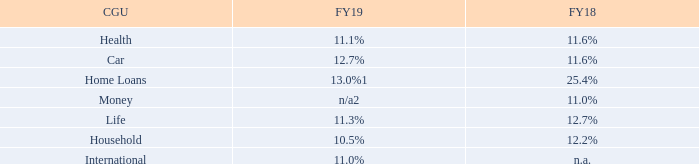Home Loans CGU
The recoverable amount of the Home loans CGU as at 31 December 2018 was determined at $5.6m based on a value-in-use calculation using cash flow projections from financial budgets approved by Senior Management covering a five-year period. The projected cash flows were updated to reflect a change in Senior Management and their initial views as part of a strategic review undertaken. The pre-tax discount rate applied to cash flow projections was 13% (30 June 2018: 25%) and cash flows beyond the five-year period were extrapolated using a 3% growth rate (30 June 2018: 3%). As a result of this analysis, management recognised an impairment charge of $4,450,000 against goodwill and capitalised software development costs. No other impairment was identified for the CGUs to which goodwill or brand names are allocated.
3.2 Goodwill and other intangible assets (continued)
Key estimates – value-in-use calculation
Cash flow projections
Our cash flow projections are based on five-year management-approved forecasts unless a longer period is justified. The forecasts use management estimates to determine income, expenses, capital expenditure and cash flows for each asset and CGU.
Discount rate
Discount rates represent the current market assessment of the risks specific to each CGU, taking into consideration the time value of money and individual risks of the underlying assets that have not been incorporated in the cash flow estimates. The discount rate calculation is based on the specific circumstances of the Group and its operating segments and is derived from its weighted average cost of capital (WACC). The WACC takes into account both debt and equity. The cost of equity is derived from the expected return on investment by the Group’s investors. The cost of debt is based on the interest bearing borrowings the Group is obliged to service. CGU-specific risk is incorporated into the WACC rate where it is considered appropriate. The pre-tax discount rates are as follows:
1 Discount rate based on impairment assessment completed on 31 December 2018 which resulted in full impairment of goodwill allocated to Home Loans CGU
2 Money CGU which consisted of the Infochoice business was sold to an independent third party on 18 February 2019. Refer to note 6.3 for details.
Growth rate estimates
For each CGU (excluding International), 5 years of cash flows have been included in the cash flow models. These are based on the long-term plan and growth rates of 3%.
Market share assumptions
These assumptions are important because management assesses how the unit’s position, relative to its competitors, might change over the budget period. Management expects the Group’s share of its respective markets to grow over the forecast period.
Sensitivity to changes in assumptions
With regard to the assessment of ‘value-in-use’ of the CGUs, management believes that no reasonable change in any of the above key assumptions would cause the carrying value of the units to materially exceed its recoverable amount.
What is the recoverable amount of the Home loans CGU as at 31 December 2018? $5.6m. What is the pre-tax discount rate applied to cash flow projections in 2019? 13%. What are the cash flow projections based on? Five-year management-approved forecasts. In which year is the health CGU higher? Find the year with the higher health CGU
Answer: fy18. In which year is the car CGU higher? Find the year with the higher car CGU
Answer: fy19. In which year is the household CGU higher? Find the year with the higher household CGU
Answer: fy18. 